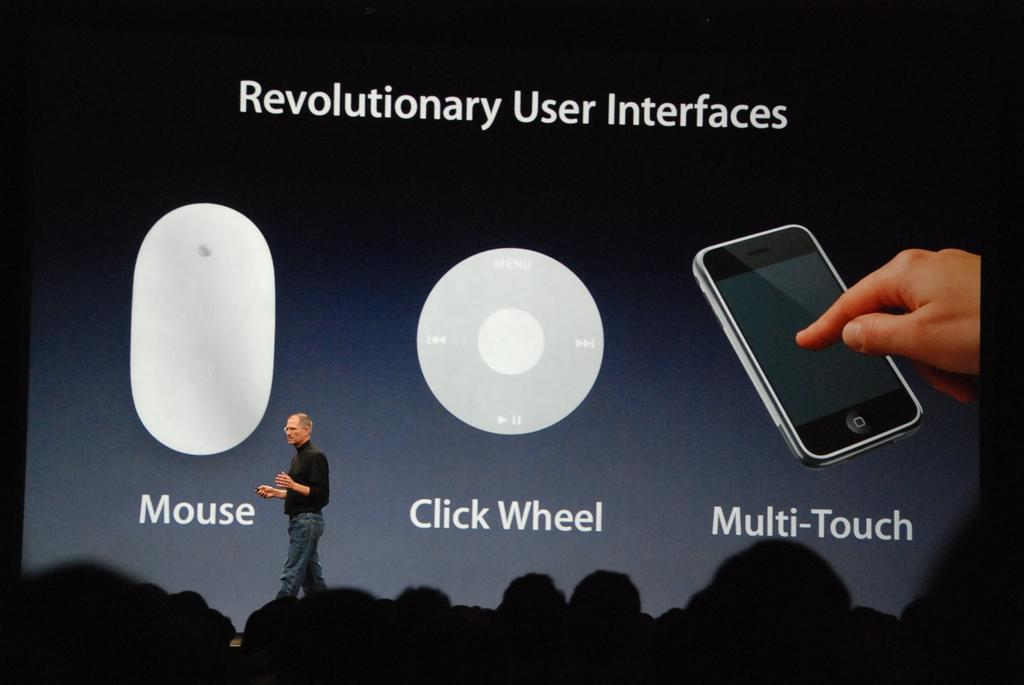Who is present in the image? There is a person in the image. What is the person wearing? The person is wearing a black shirt. Where is the person standing in the image? The person is standing on a dais. What can be seen in the background of the image? There is a screen in the background of the image. Are there any other people visible in the image? Yes, there are other people visible in the image. What type of collar can be seen on the chickens in the image? There are no chickens present in the image, so there is no collar to be seen. 